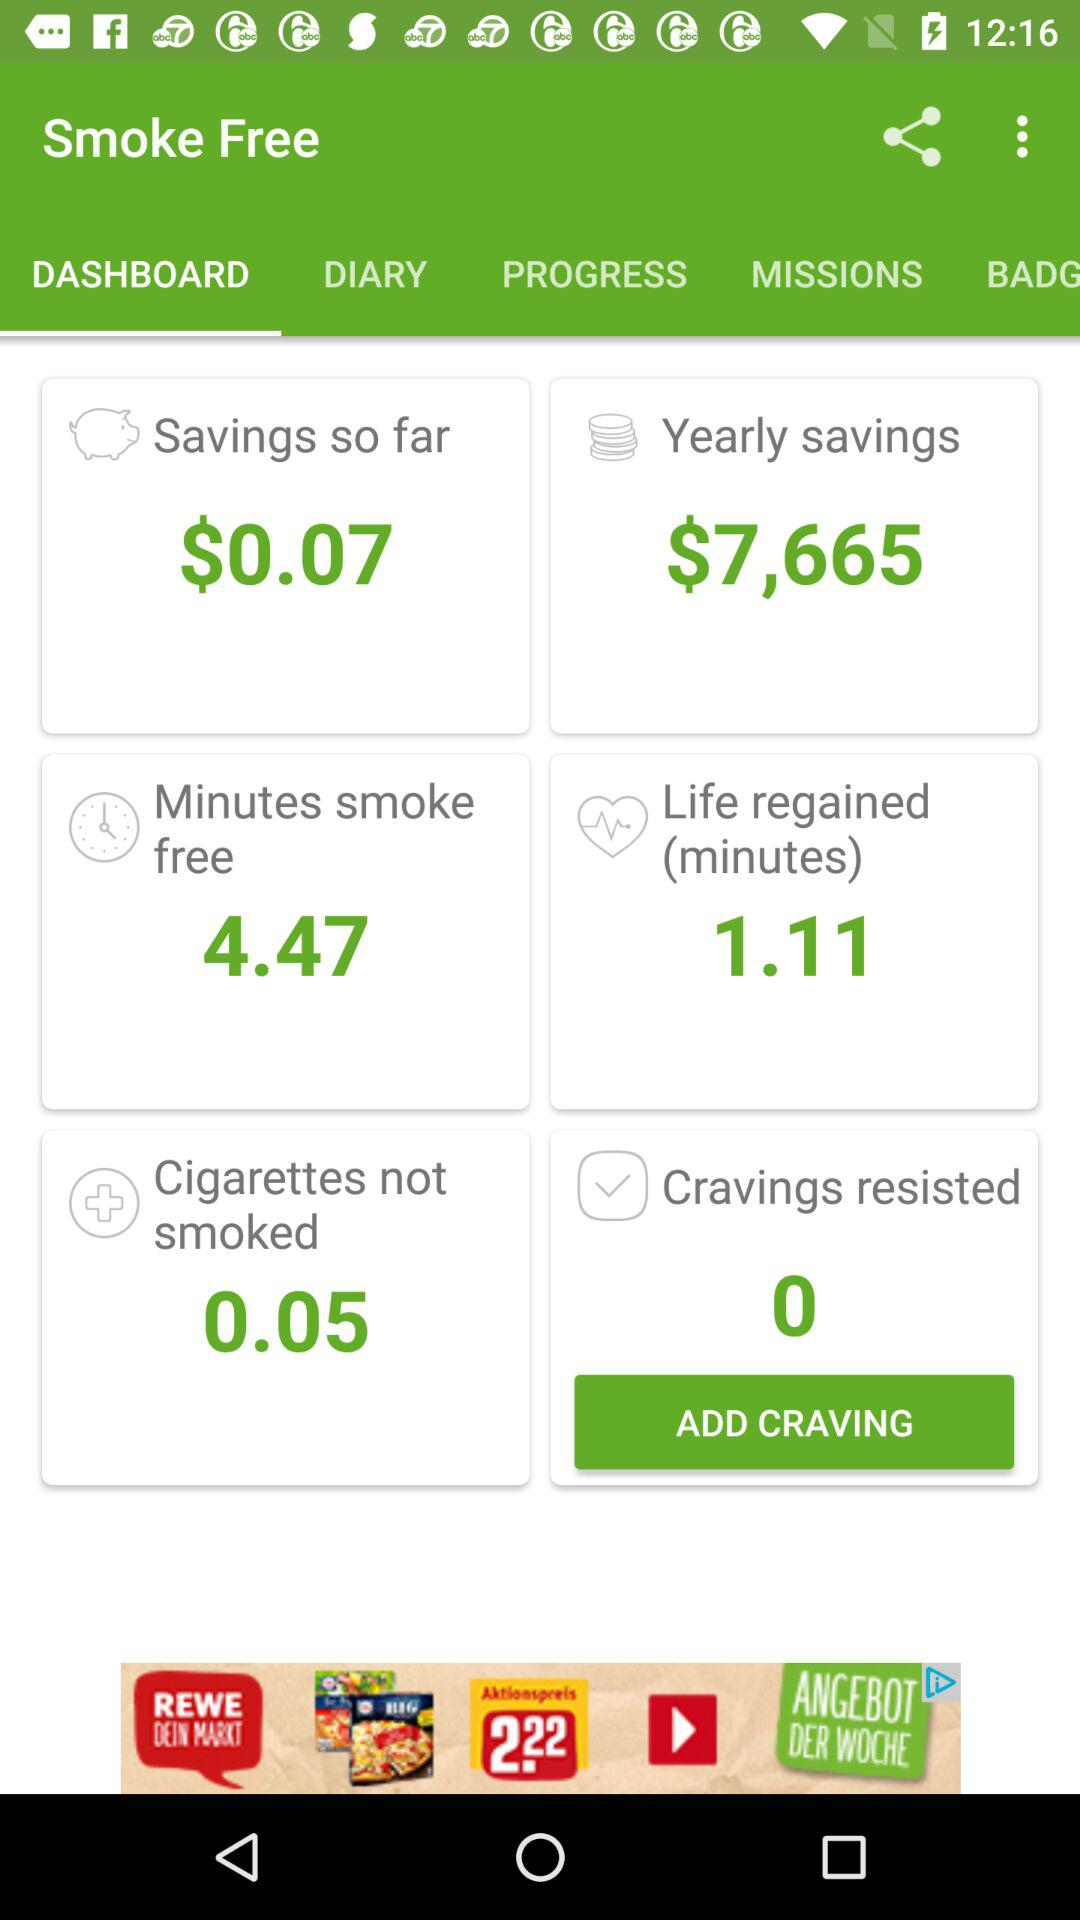How many smoke-free minutes are there? There are 4.47 smoke-free minutes. 